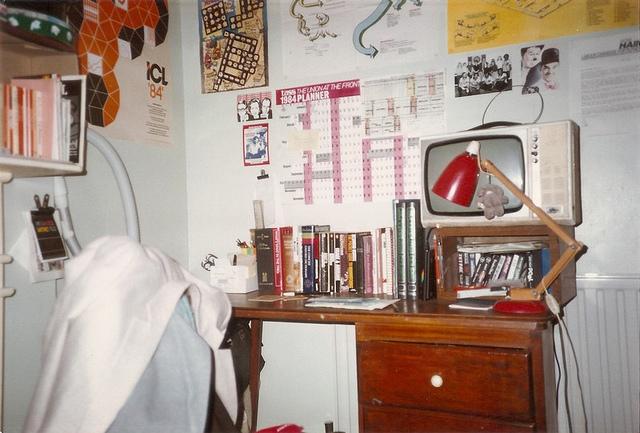What is pictured on the calendar?
Give a very brief answer. People. What is the coat hanging on?
Quick response, please. Chair. Is the TV a flat screen?
Write a very short answer. No. What color is the desk lamp?
Short answer required. Red. Is the television on?
Answer briefly. No. 